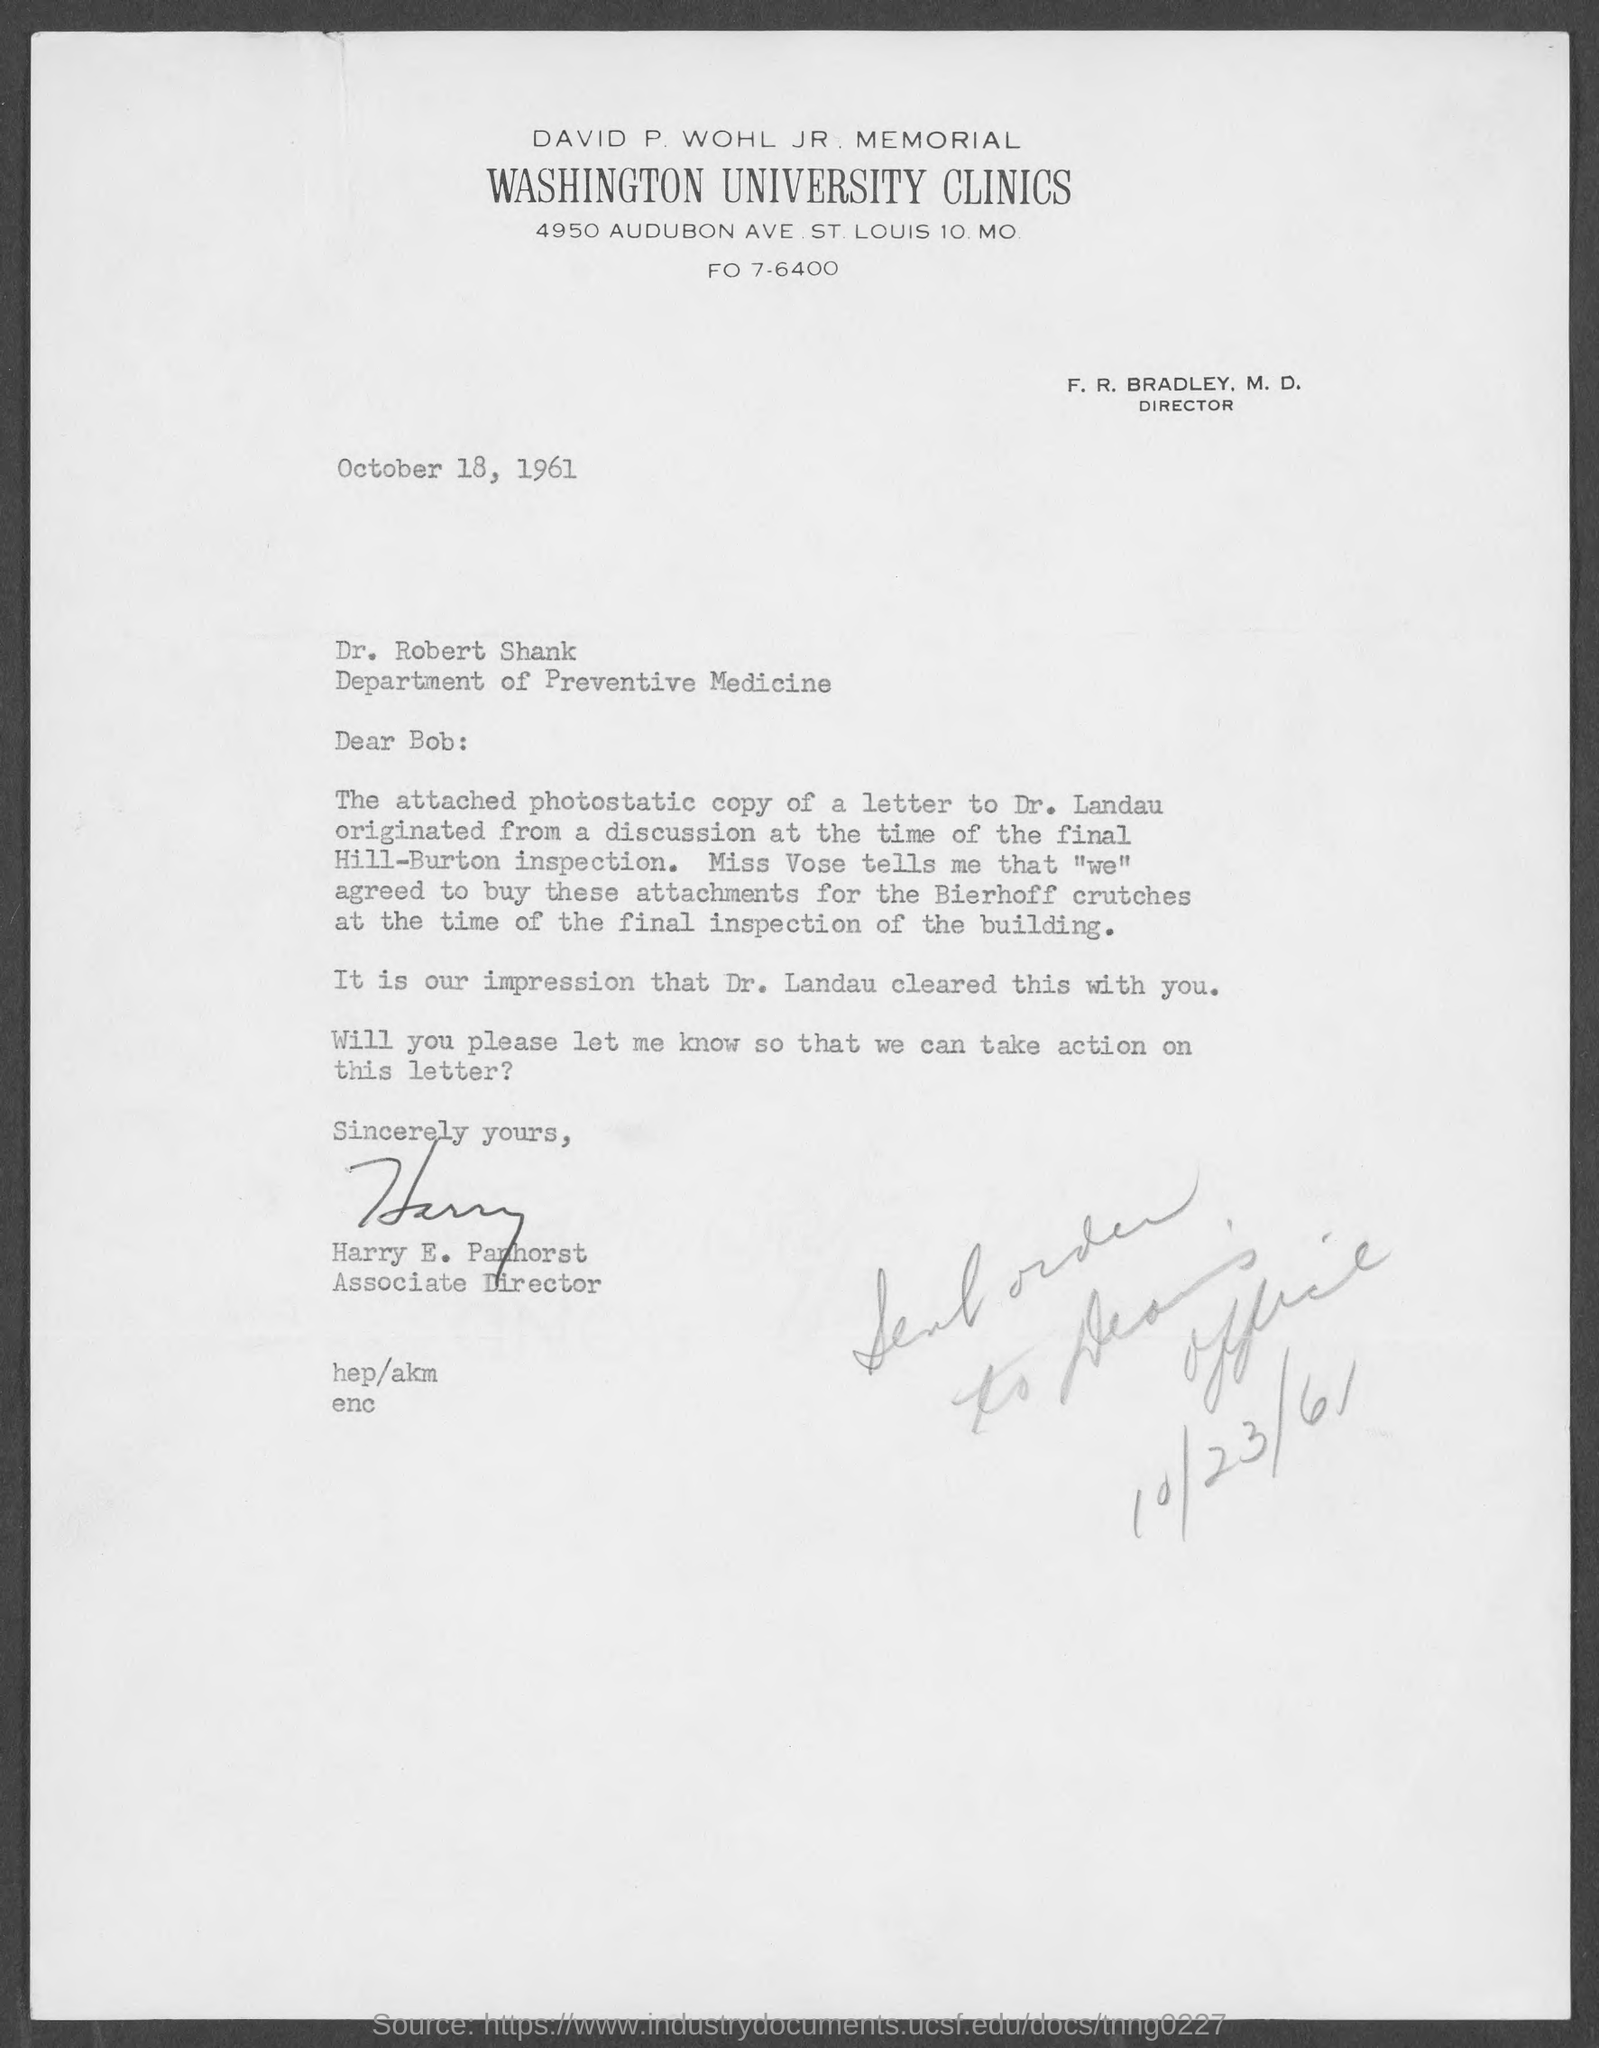What is the address of washington university clinics?
Offer a terse response. 4950 Audubon Ave. St. Louis 10. MO. Who is the associate director, washington university clinics?
Provide a short and direct response. Harry E. Panhorst. To which department does dr. robert shank belong ?
Provide a short and direct response. Department of Preventive Medicine. 